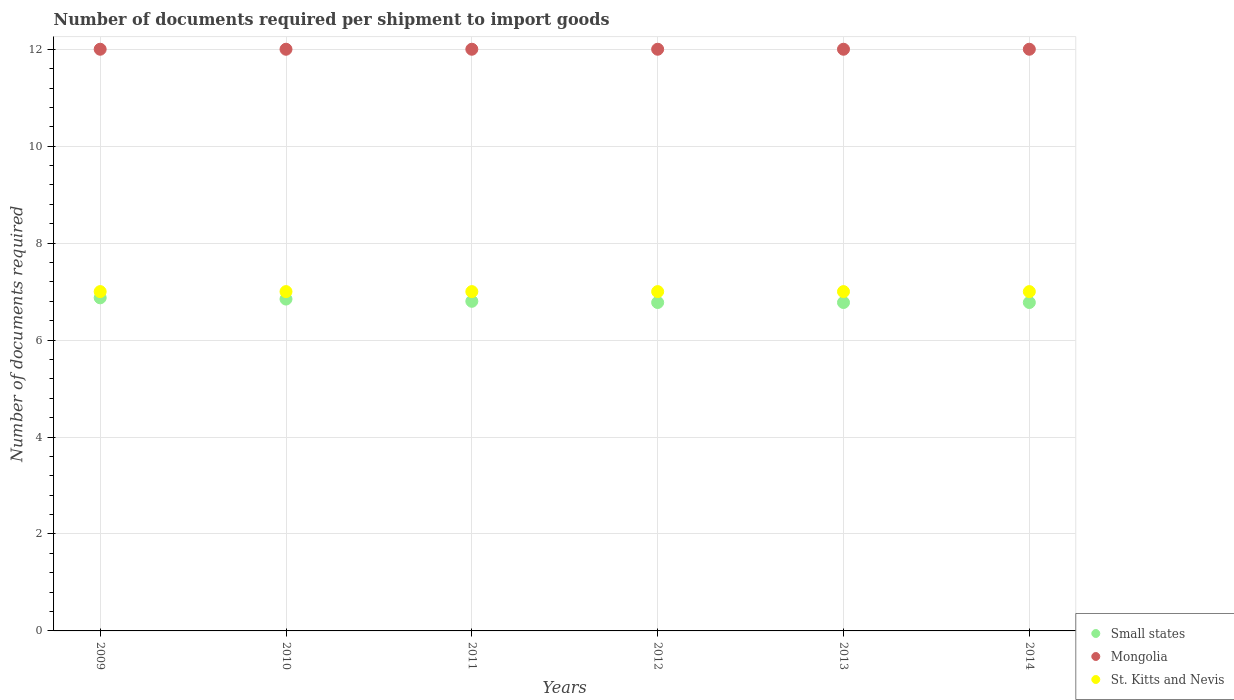What is the number of documents required per shipment to import goods in St. Kitts and Nevis in 2013?
Make the answer very short. 7. Across all years, what is the maximum number of documents required per shipment to import goods in Small states?
Provide a short and direct response. 6.87. Across all years, what is the minimum number of documents required per shipment to import goods in St. Kitts and Nevis?
Your answer should be compact. 7. What is the total number of documents required per shipment to import goods in Mongolia in the graph?
Give a very brief answer. 72. What is the difference between the number of documents required per shipment to import goods in Small states in 2009 and the number of documents required per shipment to import goods in Mongolia in 2012?
Offer a very short reply. -5.13. What is the average number of documents required per shipment to import goods in Mongolia per year?
Provide a succinct answer. 12. In the year 2014, what is the difference between the number of documents required per shipment to import goods in Small states and number of documents required per shipment to import goods in Mongolia?
Provide a succinct answer. -5.22. In how many years, is the number of documents required per shipment to import goods in St. Kitts and Nevis greater than 7.6?
Provide a succinct answer. 0. What is the ratio of the number of documents required per shipment to import goods in Small states in 2010 to that in 2014?
Provide a succinct answer. 1.01. Is the number of documents required per shipment to import goods in St. Kitts and Nevis in 2011 less than that in 2014?
Your answer should be compact. No. Is the difference between the number of documents required per shipment to import goods in Small states in 2009 and 2012 greater than the difference between the number of documents required per shipment to import goods in Mongolia in 2009 and 2012?
Your answer should be very brief. Yes. What is the difference between the highest and the lowest number of documents required per shipment to import goods in Mongolia?
Your answer should be very brief. 0. In how many years, is the number of documents required per shipment to import goods in Mongolia greater than the average number of documents required per shipment to import goods in Mongolia taken over all years?
Your answer should be very brief. 0. Is it the case that in every year, the sum of the number of documents required per shipment to import goods in Mongolia and number of documents required per shipment to import goods in St. Kitts and Nevis  is greater than the number of documents required per shipment to import goods in Small states?
Your response must be concise. Yes. Does the number of documents required per shipment to import goods in Small states monotonically increase over the years?
Your response must be concise. No. Is the number of documents required per shipment to import goods in Mongolia strictly greater than the number of documents required per shipment to import goods in Small states over the years?
Provide a short and direct response. Yes. Is the number of documents required per shipment to import goods in Mongolia strictly less than the number of documents required per shipment to import goods in St. Kitts and Nevis over the years?
Offer a very short reply. No. How many dotlines are there?
Keep it short and to the point. 3. How many years are there in the graph?
Ensure brevity in your answer.  6. What is the difference between two consecutive major ticks on the Y-axis?
Offer a very short reply. 2. Are the values on the major ticks of Y-axis written in scientific E-notation?
Ensure brevity in your answer.  No. Does the graph contain any zero values?
Keep it short and to the point. No. How are the legend labels stacked?
Offer a terse response. Vertical. What is the title of the graph?
Give a very brief answer. Number of documents required per shipment to import goods. What is the label or title of the X-axis?
Make the answer very short. Years. What is the label or title of the Y-axis?
Give a very brief answer. Number of documents required. What is the Number of documents required of Small states in 2009?
Offer a terse response. 6.87. What is the Number of documents required of Mongolia in 2009?
Keep it short and to the point. 12. What is the Number of documents required of St. Kitts and Nevis in 2009?
Your answer should be very brief. 7. What is the Number of documents required of Small states in 2010?
Ensure brevity in your answer.  6.85. What is the Number of documents required in St. Kitts and Nevis in 2010?
Keep it short and to the point. 7. What is the Number of documents required in Small states in 2011?
Provide a succinct answer. 6.8. What is the Number of documents required in Small states in 2012?
Offer a very short reply. 6.78. What is the Number of documents required of Mongolia in 2012?
Give a very brief answer. 12. What is the Number of documents required of St. Kitts and Nevis in 2012?
Give a very brief answer. 7. What is the Number of documents required of Small states in 2013?
Offer a terse response. 6.78. What is the Number of documents required of St. Kitts and Nevis in 2013?
Give a very brief answer. 7. What is the Number of documents required of Small states in 2014?
Ensure brevity in your answer.  6.78. What is the Number of documents required of St. Kitts and Nevis in 2014?
Provide a short and direct response. 7. Across all years, what is the maximum Number of documents required of Small states?
Your answer should be very brief. 6.87. Across all years, what is the maximum Number of documents required of Mongolia?
Offer a very short reply. 12. Across all years, what is the maximum Number of documents required in St. Kitts and Nevis?
Keep it short and to the point. 7. Across all years, what is the minimum Number of documents required in Small states?
Offer a very short reply. 6.78. Across all years, what is the minimum Number of documents required in St. Kitts and Nevis?
Ensure brevity in your answer.  7. What is the total Number of documents required in Small states in the graph?
Give a very brief answer. 40.84. What is the difference between the Number of documents required in Small states in 2009 and that in 2010?
Your response must be concise. 0.03. What is the difference between the Number of documents required in Small states in 2009 and that in 2011?
Make the answer very short. 0.07. What is the difference between the Number of documents required of St. Kitts and Nevis in 2009 and that in 2011?
Offer a very short reply. 0. What is the difference between the Number of documents required of Small states in 2009 and that in 2012?
Provide a short and direct response. 0.1. What is the difference between the Number of documents required in St. Kitts and Nevis in 2009 and that in 2012?
Your answer should be very brief. 0. What is the difference between the Number of documents required in Small states in 2009 and that in 2013?
Provide a short and direct response. 0.1. What is the difference between the Number of documents required of Mongolia in 2009 and that in 2013?
Make the answer very short. 0. What is the difference between the Number of documents required of St. Kitts and Nevis in 2009 and that in 2013?
Provide a short and direct response. 0. What is the difference between the Number of documents required in Small states in 2009 and that in 2014?
Your response must be concise. 0.1. What is the difference between the Number of documents required of Mongolia in 2009 and that in 2014?
Your response must be concise. 0. What is the difference between the Number of documents required in Small states in 2010 and that in 2011?
Offer a terse response. 0.05. What is the difference between the Number of documents required of Small states in 2010 and that in 2012?
Your answer should be very brief. 0.07. What is the difference between the Number of documents required of Mongolia in 2010 and that in 2012?
Offer a terse response. 0. What is the difference between the Number of documents required in Small states in 2010 and that in 2013?
Offer a terse response. 0.07. What is the difference between the Number of documents required in Small states in 2010 and that in 2014?
Give a very brief answer. 0.07. What is the difference between the Number of documents required of St. Kitts and Nevis in 2010 and that in 2014?
Your answer should be compact. 0. What is the difference between the Number of documents required of Small states in 2011 and that in 2012?
Offer a terse response. 0.03. What is the difference between the Number of documents required in Small states in 2011 and that in 2013?
Give a very brief answer. 0.03. What is the difference between the Number of documents required of Small states in 2011 and that in 2014?
Give a very brief answer. 0.03. What is the difference between the Number of documents required in Mongolia in 2011 and that in 2014?
Provide a succinct answer. 0. What is the difference between the Number of documents required of St. Kitts and Nevis in 2011 and that in 2014?
Offer a very short reply. 0. What is the difference between the Number of documents required of Mongolia in 2012 and that in 2013?
Keep it short and to the point. 0. What is the difference between the Number of documents required in Small states in 2012 and that in 2014?
Offer a very short reply. 0. What is the difference between the Number of documents required of St. Kitts and Nevis in 2012 and that in 2014?
Offer a very short reply. 0. What is the difference between the Number of documents required of Small states in 2013 and that in 2014?
Ensure brevity in your answer.  0. What is the difference between the Number of documents required in Small states in 2009 and the Number of documents required in Mongolia in 2010?
Ensure brevity in your answer.  -5.13. What is the difference between the Number of documents required in Small states in 2009 and the Number of documents required in St. Kitts and Nevis in 2010?
Provide a short and direct response. -0.13. What is the difference between the Number of documents required in Small states in 2009 and the Number of documents required in Mongolia in 2011?
Your answer should be compact. -5.13. What is the difference between the Number of documents required of Small states in 2009 and the Number of documents required of St. Kitts and Nevis in 2011?
Your answer should be compact. -0.13. What is the difference between the Number of documents required in Mongolia in 2009 and the Number of documents required in St. Kitts and Nevis in 2011?
Your response must be concise. 5. What is the difference between the Number of documents required in Small states in 2009 and the Number of documents required in Mongolia in 2012?
Provide a succinct answer. -5.13. What is the difference between the Number of documents required of Small states in 2009 and the Number of documents required of St. Kitts and Nevis in 2012?
Ensure brevity in your answer.  -0.13. What is the difference between the Number of documents required of Mongolia in 2009 and the Number of documents required of St. Kitts and Nevis in 2012?
Give a very brief answer. 5. What is the difference between the Number of documents required of Small states in 2009 and the Number of documents required of Mongolia in 2013?
Offer a very short reply. -5.13. What is the difference between the Number of documents required of Small states in 2009 and the Number of documents required of St. Kitts and Nevis in 2013?
Give a very brief answer. -0.13. What is the difference between the Number of documents required in Small states in 2009 and the Number of documents required in Mongolia in 2014?
Offer a very short reply. -5.13. What is the difference between the Number of documents required in Small states in 2009 and the Number of documents required in St. Kitts and Nevis in 2014?
Provide a succinct answer. -0.13. What is the difference between the Number of documents required of Mongolia in 2009 and the Number of documents required of St. Kitts and Nevis in 2014?
Provide a short and direct response. 5. What is the difference between the Number of documents required of Small states in 2010 and the Number of documents required of Mongolia in 2011?
Your response must be concise. -5.15. What is the difference between the Number of documents required in Small states in 2010 and the Number of documents required in St. Kitts and Nevis in 2011?
Your response must be concise. -0.15. What is the difference between the Number of documents required of Mongolia in 2010 and the Number of documents required of St. Kitts and Nevis in 2011?
Provide a short and direct response. 5. What is the difference between the Number of documents required in Small states in 2010 and the Number of documents required in Mongolia in 2012?
Your answer should be very brief. -5.15. What is the difference between the Number of documents required in Small states in 2010 and the Number of documents required in St. Kitts and Nevis in 2012?
Make the answer very short. -0.15. What is the difference between the Number of documents required of Mongolia in 2010 and the Number of documents required of St. Kitts and Nevis in 2012?
Keep it short and to the point. 5. What is the difference between the Number of documents required in Small states in 2010 and the Number of documents required in Mongolia in 2013?
Offer a terse response. -5.15. What is the difference between the Number of documents required in Small states in 2010 and the Number of documents required in St. Kitts and Nevis in 2013?
Provide a succinct answer. -0.15. What is the difference between the Number of documents required in Mongolia in 2010 and the Number of documents required in St. Kitts and Nevis in 2013?
Your answer should be very brief. 5. What is the difference between the Number of documents required of Small states in 2010 and the Number of documents required of Mongolia in 2014?
Ensure brevity in your answer.  -5.15. What is the difference between the Number of documents required in Small states in 2010 and the Number of documents required in St. Kitts and Nevis in 2014?
Make the answer very short. -0.15. What is the difference between the Number of documents required in Mongolia in 2010 and the Number of documents required in St. Kitts and Nevis in 2014?
Your answer should be very brief. 5. What is the difference between the Number of documents required in Small states in 2011 and the Number of documents required in St. Kitts and Nevis in 2012?
Your answer should be compact. -0.2. What is the difference between the Number of documents required of Mongolia in 2011 and the Number of documents required of St. Kitts and Nevis in 2012?
Make the answer very short. 5. What is the difference between the Number of documents required in Mongolia in 2011 and the Number of documents required in St. Kitts and Nevis in 2013?
Keep it short and to the point. 5. What is the difference between the Number of documents required of Small states in 2011 and the Number of documents required of St. Kitts and Nevis in 2014?
Give a very brief answer. -0.2. What is the difference between the Number of documents required of Small states in 2012 and the Number of documents required of Mongolia in 2013?
Your answer should be very brief. -5.22. What is the difference between the Number of documents required of Small states in 2012 and the Number of documents required of St. Kitts and Nevis in 2013?
Offer a very short reply. -0.23. What is the difference between the Number of documents required of Small states in 2012 and the Number of documents required of Mongolia in 2014?
Ensure brevity in your answer.  -5.22. What is the difference between the Number of documents required of Small states in 2012 and the Number of documents required of St. Kitts and Nevis in 2014?
Your answer should be compact. -0.23. What is the difference between the Number of documents required of Mongolia in 2012 and the Number of documents required of St. Kitts and Nevis in 2014?
Provide a short and direct response. 5. What is the difference between the Number of documents required in Small states in 2013 and the Number of documents required in Mongolia in 2014?
Give a very brief answer. -5.22. What is the difference between the Number of documents required in Small states in 2013 and the Number of documents required in St. Kitts and Nevis in 2014?
Give a very brief answer. -0.23. What is the average Number of documents required in Small states per year?
Offer a terse response. 6.81. What is the average Number of documents required of St. Kitts and Nevis per year?
Provide a succinct answer. 7. In the year 2009, what is the difference between the Number of documents required of Small states and Number of documents required of Mongolia?
Offer a very short reply. -5.13. In the year 2009, what is the difference between the Number of documents required of Small states and Number of documents required of St. Kitts and Nevis?
Your answer should be very brief. -0.13. In the year 2009, what is the difference between the Number of documents required of Mongolia and Number of documents required of St. Kitts and Nevis?
Provide a succinct answer. 5. In the year 2010, what is the difference between the Number of documents required of Small states and Number of documents required of Mongolia?
Keep it short and to the point. -5.15. In the year 2010, what is the difference between the Number of documents required of Small states and Number of documents required of St. Kitts and Nevis?
Your answer should be very brief. -0.15. In the year 2011, what is the difference between the Number of documents required of Small states and Number of documents required of Mongolia?
Provide a short and direct response. -5.2. In the year 2012, what is the difference between the Number of documents required of Small states and Number of documents required of Mongolia?
Your response must be concise. -5.22. In the year 2012, what is the difference between the Number of documents required of Small states and Number of documents required of St. Kitts and Nevis?
Provide a short and direct response. -0.23. In the year 2012, what is the difference between the Number of documents required in Mongolia and Number of documents required in St. Kitts and Nevis?
Offer a very short reply. 5. In the year 2013, what is the difference between the Number of documents required in Small states and Number of documents required in Mongolia?
Ensure brevity in your answer.  -5.22. In the year 2013, what is the difference between the Number of documents required of Small states and Number of documents required of St. Kitts and Nevis?
Provide a succinct answer. -0.23. In the year 2014, what is the difference between the Number of documents required of Small states and Number of documents required of Mongolia?
Give a very brief answer. -5.22. In the year 2014, what is the difference between the Number of documents required in Small states and Number of documents required in St. Kitts and Nevis?
Keep it short and to the point. -0.23. In the year 2014, what is the difference between the Number of documents required in Mongolia and Number of documents required in St. Kitts and Nevis?
Provide a succinct answer. 5. What is the ratio of the Number of documents required of Mongolia in 2009 to that in 2010?
Offer a terse response. 1. What is the ratio of the Number of documents required of Small states in 2009 to that in 2011?
Your answer should be compact. 1.01. What is the ratio of the Number of documents required of Mongolia in 2009 to that in 2011?
Your answer should be compact. 1. What is the ratio of the Number of documents required in St. Kitts and Nevis in 2009 to that in 2011?
Give a very brief answer. 1. What is the ratio of the Number of documents required in Small states in 2009 to that in 2012?
Keep it short and to the point. 1.01. What is the ratio of the Number of documents required in Mongolia in 2009 to that in 2012?
Ensure brevity in your answer.  1. What is the ratio of the Number of documents required of Small states in 2009 to that in 2013?
Offer a terse response. 1.01. What is the ratio of the Number of documents required of St. Kitts and Nevis in 2009 to that in 2013?
Provide a short and direct response. 1. What is the ratio of the Number of documents required of Small states in 2009 to that in 2014?
Give a very brief answer. 1.01. What is the ratio of the Number of documents required in St. Kitts and Nevis in 2009 to that in 2014?
Your answer should be very brief. 1. What is the ratio of the Number of documents required of Small states in 2010 to that in 2011?
Offer a very short reply. 1.01. What is the ratio of the Number of documents required in Mongolia in 2010 to that in 2011?
Provide a succinct answer. 1. What is the ratio of the Number of documents required in St. Kitts and Nevis in 2010 to that in 2011?
Offer a very short reply. 1. What is the ratio of the Number of documents required of Small states in 2010 to that in 2012?
Offer a terse response. 1.01. What is the ratio of the Number of documents required in St. Kitts and Nevis in 2010 to that in 2012?
Your answer should be compact. 1. What is the ratio of the Number of documents required in Small states in 2010 to that in 2013?
Make the answer very short. 1.01. What is the ratio of the Number of documents required of Small states in 2010 to that in 2014?
Your response must be concise. 1.01. What is the ratio of the Number of documents required of Mongolia in 2010 to that in 2014?
Provide a short and direct response. 1. What is the ratio of the Number of documents required of Small states in 2011 to that in 2012?
Ensure brevity in your answer.  1. What is the ratio of the Number of documents required of Mongolia in 2011 to that in 2012?
Your answer should be very brief. 1. What is the ratio of the Number of documents required of St. Kitts and Nevis in 2011 to that in 2012?
Your answer should be compact. 1. What is the ratio of the Number of documents required of Mongolia in 2011 to that in 2013?
Your response must be concise. 1. What is the ratio of the Number of documents required in St. Kitts and Nevis in 2011 to that in 2013?
Your response must be concise. 1. What is the ratio of the Number of documents required of Small states in 2011 to that in 2014?
Keep it short and to the point. 1. What is the ratio of the Number of documents required of Mongolia in 2011 to that in 2014?
Ensure brevity in your answer.  1. What is the ratio of the Number of documents required in St. Kitts and Nevis in 2011 to that in 2014?
Ensure brevity in your answer.  1. What is the ratio of the Number of documents required in Small states in 2012 to that in 2013?
Your response must be concise. 1. What is the ratio of the Number of documents required in St. Kitts and Nevis in 2012 to that in 2013?
Offer a terse response. 1. What is the ratio of the Number of documents required of Small states in 2012 to that in 2014?
Give a very brief answer. 1. What is the ratio of the Number of documents required in St. Kitts and Nevis in 2012 to that in 2014?
Your response must be concise. 1. What is the ratio of the Number of documents required of Mongolia in 2013 to that in 2014?
Provide a succinct answer. 1. What is the difference between the highest and the second highest Number of documents required in Small states?
Offer a very short reply. 0.03. What is the difference between the highest and the lowest Number of documents required in Small states?
Offer a terse response. 0.1. What is the difference between the highest and the lowest Number of documents required in Mongolia?
Your answer should be compact. 0. 